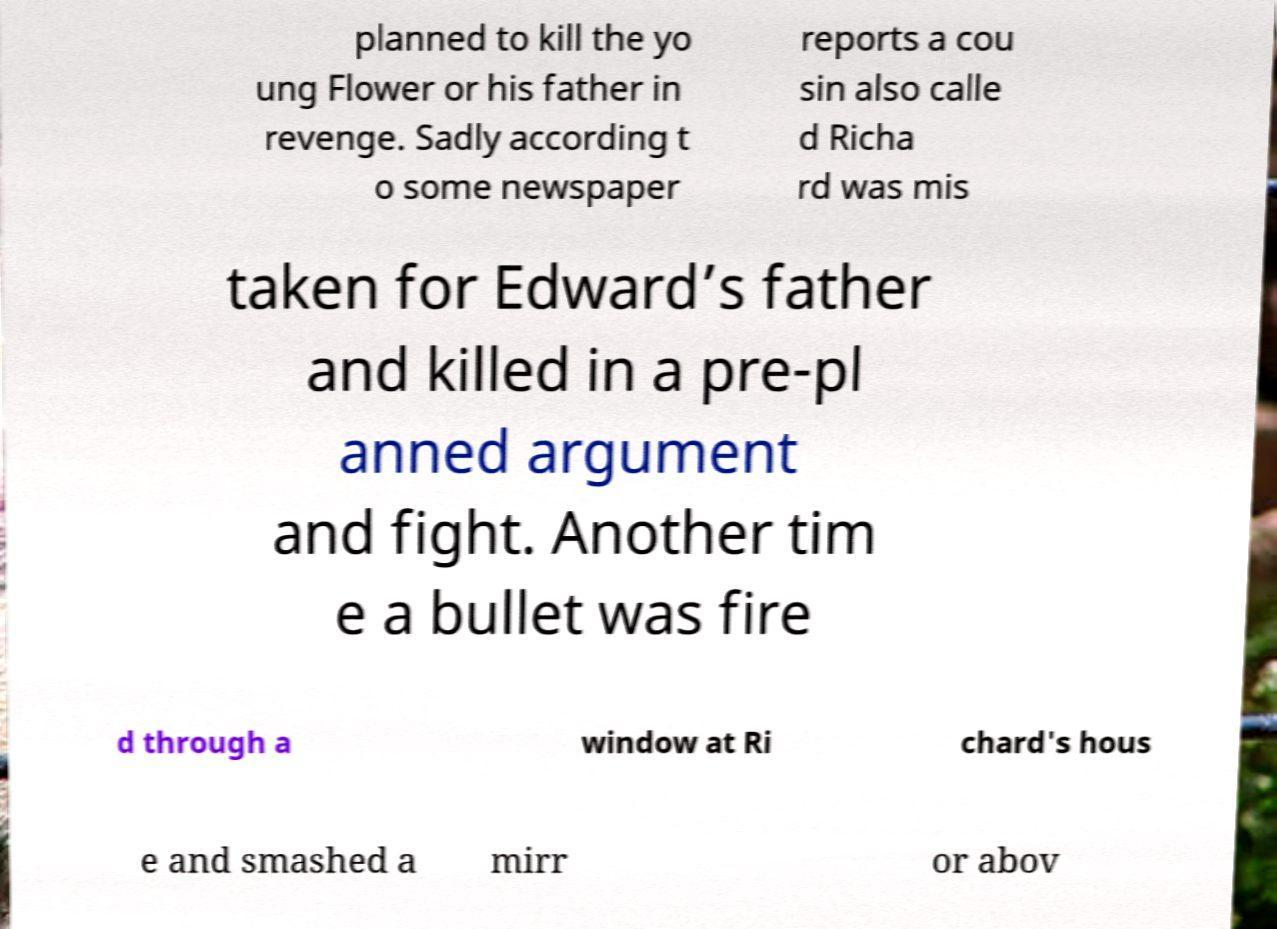For documentation purposes, I need the text within this image transcribed. Could you provide that? planned to kill the yo ung Flower or his father in revenge. Sadly according t o some newspaper reports a cou sin also calle d Richa rd was mis taken for Edward’s father and killed in a pre-pl anned argument and fight. Another tim e a bullet was fire d through a window at Ri chard's hous e and smashed a mirr or abov 